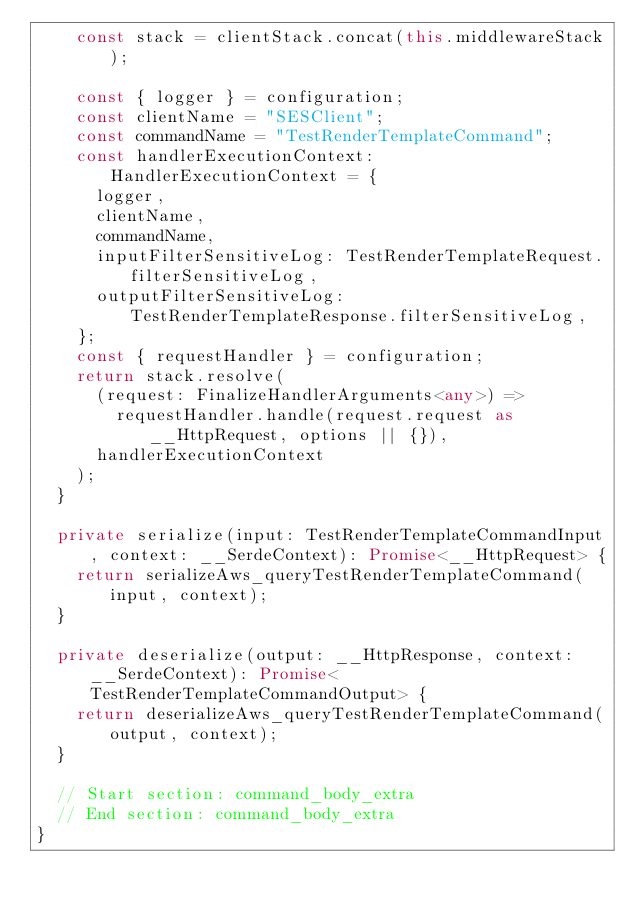Convert code to text. <code><loc_0><loc_0><loc_500><loc_500><_TypeScript_>    const stack = clientStack.concat(this.middlewareStack);

    const { logger } = configuration;
    const clientName = "SESClient";
    const commandName = "TestRenderTemplateCommand";
    const handlerExecutionContext: HandlerExecutionContext = {
      logger,
      clientName,
      commandName,
      inputFilterSensitiveLog: TestRenderTemplateRequest.filterSensitiveLog,
      outputFilterSensitiveLog: TestRenderTemplateResponse.filterSensitiveLog,
    };
    const { requestHandler } = configuration;
    return stack.resolve(
      (request: FinalizeHandlerArguments<any>) =>
        requestHandler.handle(request.request as __HttpRequest, options || {}),
      handlerExecutionContext
    );
  }

  private serialize(input: TestRenderTemplateCommandInput, context: __SerdeContext): Promise<__HttpRequest> {
    return serializeAws_queryTestRenderTemplateCommand(input, context);
  }

  private deserialize(output: __HttpResponse, context: __SerdeContext): Promise<TestRenderTemplateCommandOutput> {
    return deserializeAws_queryTestRenderTemplateCommand(output, context);
  }

  // Start section: command_body_extra
  // End section: command_body_extra
}
</code> 